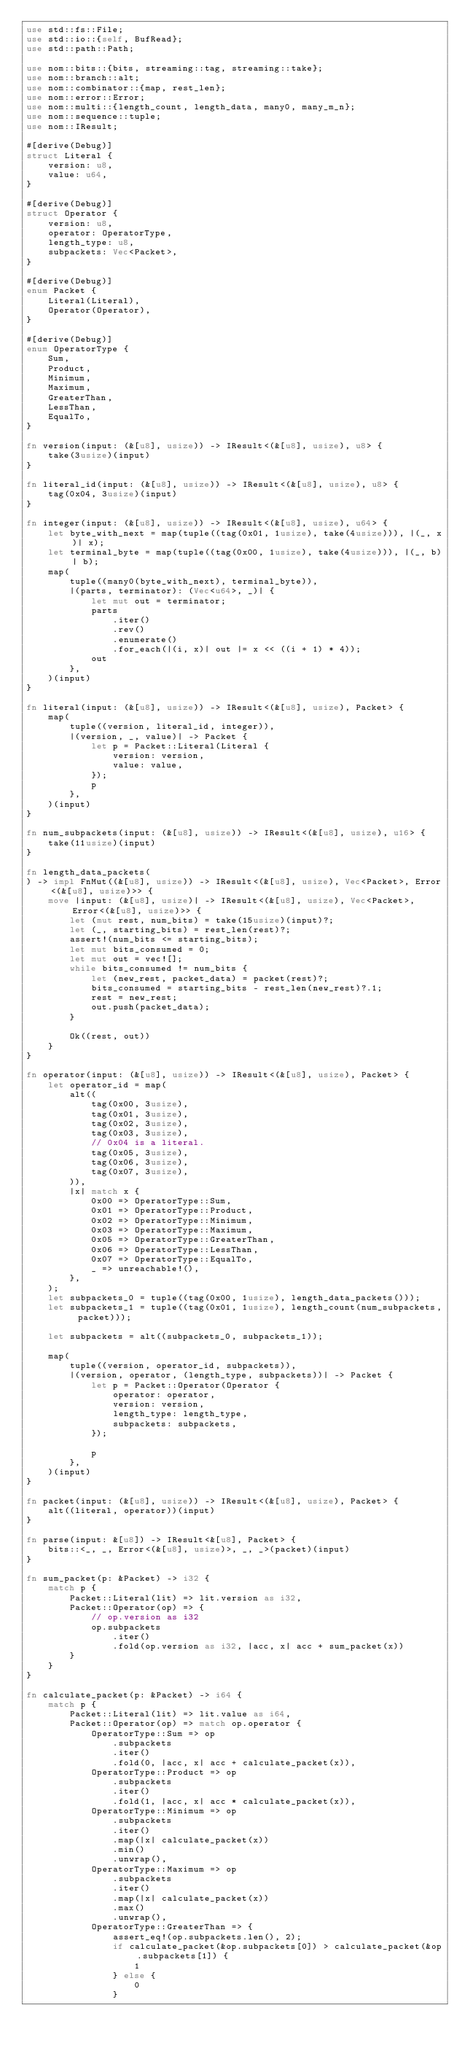<code> <loc_0><loc_0><loc_500><loc_500><_Rust_>use std::fs::File;
use std::io::{self, BufRead};
use std::path::Path;

use nom::bits::{bits, streaming::tag, streaming::take};
use nom::branch::alt;
use nom::combinator::{map, rest_len};
use nom::error::Error;
use nom::multi::{length_count, length_data, many0, many_m_n};
use nom::sequence::tuple;
use nom::IResult;

#[derive(Debug)]
struct Literal {
    version: u8,
    value: u64,
}

#[derive(Debug)]
struct Operator {
    version: u8,
    operator: OperatorType,
    length_type: u8,
    subpackets: Vec<Packet>,
}

#[derive(Debug)]
enum Packet {
    Literal(Literal),
    Operator(Operator),
}

#[derive(Debug)]
enum OperatorType {
    Sum,
    Product,
    Minimum,
    Maximum,
    GreaterThan,
    LessThan,
    EqualTo,
}

fn version(input: (&[u8], usize)) -> IResult<(&[u8], usize), u8> {
    take(3usize)(input)
}

fn literal_id(input: (&[u8], usize)) -> IResult<(&[u8], usize), u8> {
    tag(0x04, 3usize)(input)
}

fn integer(input: (&[u8], usize)) -> IResult<(&[u8], usize), u64> {
    let byte_with_next = map(tuple((tag(0x01, 1usize), take(4usize))), |(_, x)| x);
    let terminal_byte = map(tuple((tag(0x00, 1usize), take(4usize))), |(_, b)| b);
    map(
        tuple((many0(byte_with_next), terminal_byte)),
        |(parts, terminator): (Vec<u64>, _)| {
            let mut out = terminator;
            parts
                .iter()
                .rev()
                .enumerate()
                .for_each(|(i, x)| out |= x << ((i + 1) * 4));
            out
        },
    )(input)
}

fn literal(input: (&[u8], usize)) -> IResult<(&[u8], usize), Packet> {
    map(
        tuple((version, literal_id, integer)),
        |(version, _, value)| -> Packet {
            let p = Packet::Literal(Literal {
                version: version,
                value: value,
            });
            p
        },
    )(input)
}

fn num_subpackets(input: (&[u8], usize)) -> IResult<(&[u8], usize), u16> {
    take(11usize)(input)
}

fn length_data_packets(
) -> impl FnMut((&[u8], usize)) -> IResult<(&[u8], usize), Vec<Packet>, Error<(&[u8], usize)>> {
    move |input: (&[u8], usize)| -> IResult<(&[u8], usize), Vec<Packet>, Error<(&[u8], usize)>> {
        let (mut rest, num_bits) = take(15usize)(input)?;
        let (_, starting_bits) = rest_len(rest)?;
        assert!(num_bits <= starting_bits);
        let mut bits_consumed = 0;
        let mut out = vec![];
        while bits_consumed != num_bits {
            let (new_rest, packet_data) = packet(rest)?;
            bits_consumed = starting_bits - rest_len(new_rest)?.1;
            rest = new_rest;
            out.push(packet_data);
        }

        Ok((rest, out))
    }
}

fn operator(input: (&[u8], usize)) -> IResult<(&[u8], usize), Packet> {
    let operator_id = map(
        alt((
            tag(0x00, 3usize),
            tag(0x01, 3usize),
            tag(0x02, 3usize),
            tag(0x03, 3usize),
            // 0x04 is a literal.
            tag(0x05, 3usize),
            tag(0x06, 3usize),
            tag(0x07, 3usize),
        )),
        |x| match x {
            0x00 => OperatorType::Sum,
            0x01 => OperatorType::Product,
            0x02 => OperatorType::Minimum,
            0x03 => OperatorType::Maximum,
            0x05 => OperatorType::GreaterThan,
            0x06 => OperatorType::LessThan,
            0x07 => OperatorType::EqualTo,
            _ => unreachable!(),
        },
    );
    let subpackets_0 = tuple((tag(0x00, 1usize), length_data_packets()));
    let subpackets_1 = tuple((tag(0x01, 1usize), length_count(num_subpackets, packet)));

    let subpackets = alt((subpackets_0, subpackets_1));

    map(
        tuple((version, operator_id, subpackets)),
        |(version, operator, (length_type, subpackets))| -> Packet {
            let p = Packet::Operator(Operator {
                operator: operator,
                version: version,
                length_type: length_type,
                subpackets: subpackets,
            });

            p
        },
    )(input)
}

fn packet(input: (&[u8], usize)) -> IResult<(&[u8], usize), Packet> {
    alt((literal, operator))(input)
}

fn parse(input: &[u8]) -> IResult<&[u8], Packet> {
    bits::<_, _, Error<(&[u8], usize)>, _, _>(packet)(input)
}

fn sum_packet(p: &Packet) -> i32 {
    match p {
        Packet::Literal(lit) => lit.version as i32,
        Packet::Operator(op) => {
            // op.version as i32
            op.subpackets
                .iter()
                .fold(op.version as i32, |acc, x| acc + sum_packet(x))
        }
    }
}

fn calculate_packet(p: &Packet) -> i64 {
    match p {
        Packet::Literal(lit) => lit.value as i64,
        Packet::Operator(op) => match op.operator {
            OperatorType::Sum => op
                .subpackets
                .iter()
                .fold(0, |acc, x| acc + calculate_packet(x)),
            OperatorType::Product => op
                .subpackets
                .iter()
                .fold(1, |acc, x| acc * calculate_packet(x)),
            OperatorType::Minimum => op
                .subpackets
                .iter()
                .map(|x| calculate_packet(x))
                .min()
                .unwrap(),
            OperatorType::Maximum => op
                .subpackets
                .iter()
                .map(|x| calculate_packet(x))
                .max()
                .unwrap(),
            OperatorType::GreaterThan => {
                assert_eq!(op.subpackets.len(), 2);
                if calculate_packet(&op.subpackets[0]) > calculate_packet(&op.subpackets[1]) {
                    1
                } else {
                    0
                }</code> 